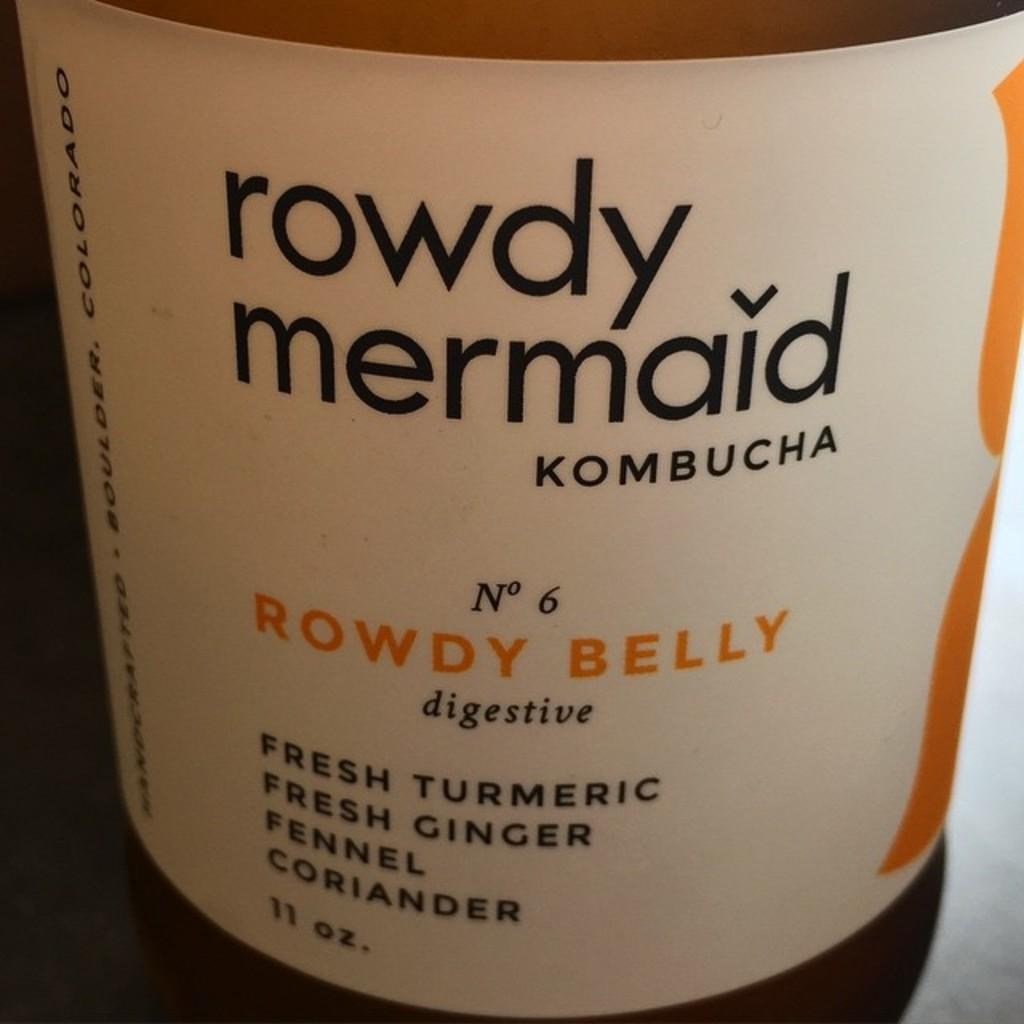<image>
Write a terse but informative summary of the picture. Bottle of Rowdy Mermaid kombucha with a white label. 